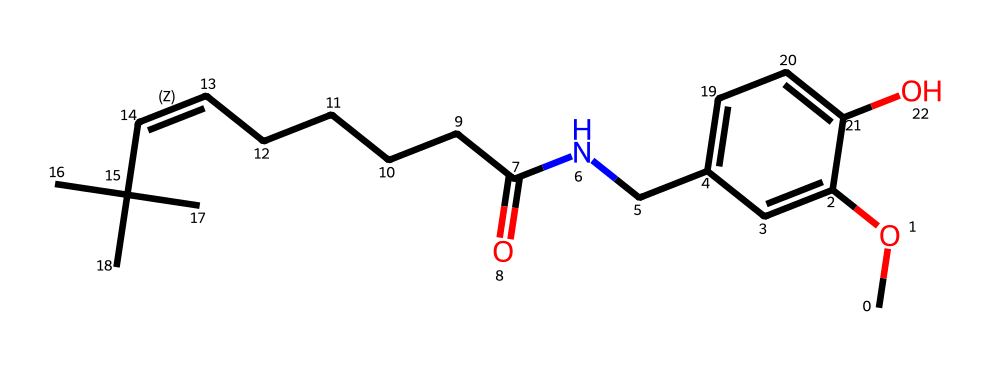What is the main functional group present in this compound? The compound contains an ether (CO) and a hydroxyl group (OH), indicating that it has both an ether and alcohol functional group. Here, the ether functional group is represented by the presence of the –O– connected to the aromatic ring, while the hydroxyl group is indicated by the –OH connected to the aromatic ring.
Answer: ether and alcohol How many carbon atoms are in the molecular structure? Counting the number of carbon atoms in the structure, there are 15 carbon atoms present, including those in the aromatic ring, the aliphatic chain, and the functional groups attached to them.
Answer: 15 Does this compound have any nitrogen atoms? The SMILES representation shows a nitrogen atom (N) present in the structure, which is part of the amide functional group connected to the carbon chain.
Answer: yes What type of compound is oleoresin capsicum classified as? Oleoresin capsicum is classified as a natural extract containing capsaicin, which is the active component. Based on its structure, it falls under the category of a secondary metabolite known as a phenolic compound.
Answer: phenolic compound How many bonds are between the carbon atoms in the chain? In the aliphatic chain of the compound, there are 11 carbon atoms that are connected by single bonds (C–C) and one double bond (C=C), resulting in a total of 10 single bonds and 1 double bond between the carbon atoms.
Answer: 10 single bonds and 1 double bond What type of chemical behavior can we expect from this structure? Given the presence of multiple functional groups, including the hydroxyl, ether, and nitrogen groups, we can anticipate that this compound will exhibit behavior characteristic of natural extracts, including anti-inflammatory properties and irritation effects. This behavior is influenced by the polar nature of the hydroxyl group and the branched carbon chains.
Answer: anti-inflammatory and irritation effects 